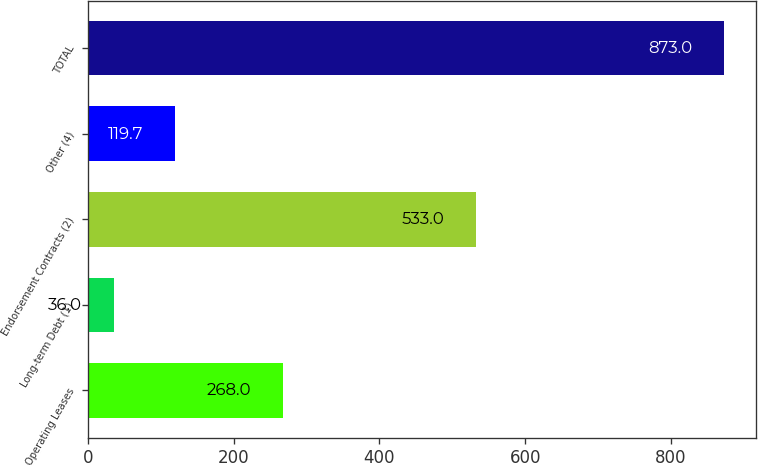Convert chart to OTSL. <chart><loc_0><loc_0><loc_500><loc_500><bar_chart><fcel>Operating Leases<fcel>Long-term Debt (1)<fcel>Endorsement Contracts (2)<fcel>Other (4)<fcel>TOTAL<nl><fcel>268<fcel>36<fcel>533<fcel>119.7<fcel>873<nl></chart> 